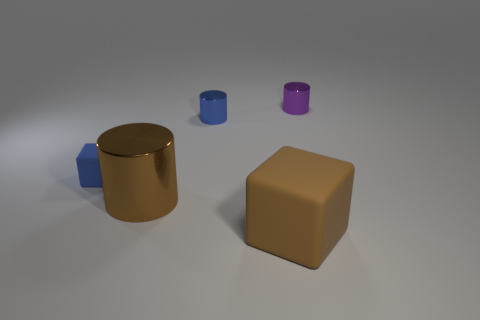Subtract all purple metal cylinders. How many cylinders are left? 2 Add 2 big metallic cylinders. How many objects exist? 7 Subtract all blue cylinders. How many cylinders are left? 2 Subtract all cylinders. How many objects are left? 2 Subtract 2 cubes. How many cubes are left? 0 Subtract all blue cylinders. Subtract all brown spheres. How many cylinders are left? 2 Subtract all cyan spheres. How many brown blocks are left? 1 Subtract all metallic things. Subtract all tiny brown metallic spheres. How many objects are left? 2 Add 2 tiny rubber things. How many tiny rubber things are left? 3 Add 4 tiny gray shiny spheres. How many tiny gray shiny spheres exist? 4 